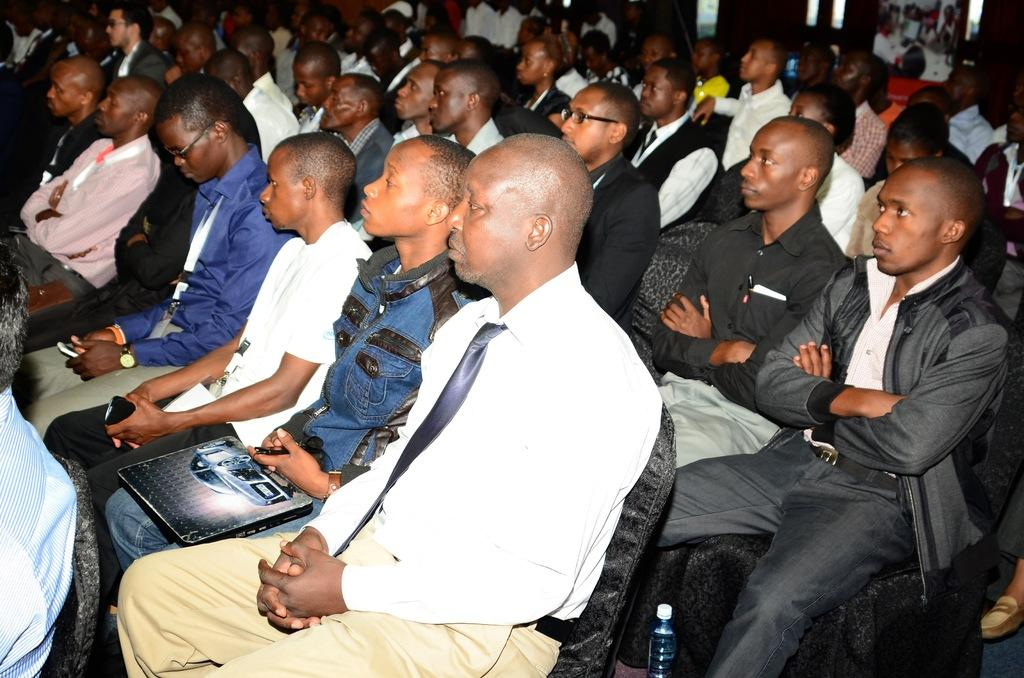What is present in the image? There are people in the image. What are the people doing in the image? The people are sitting on chairs. Can you see a hill in the background of the image? There is no hill visible in the image. What type of flag is being waved by the people in the image? There is no flag present in the image. 